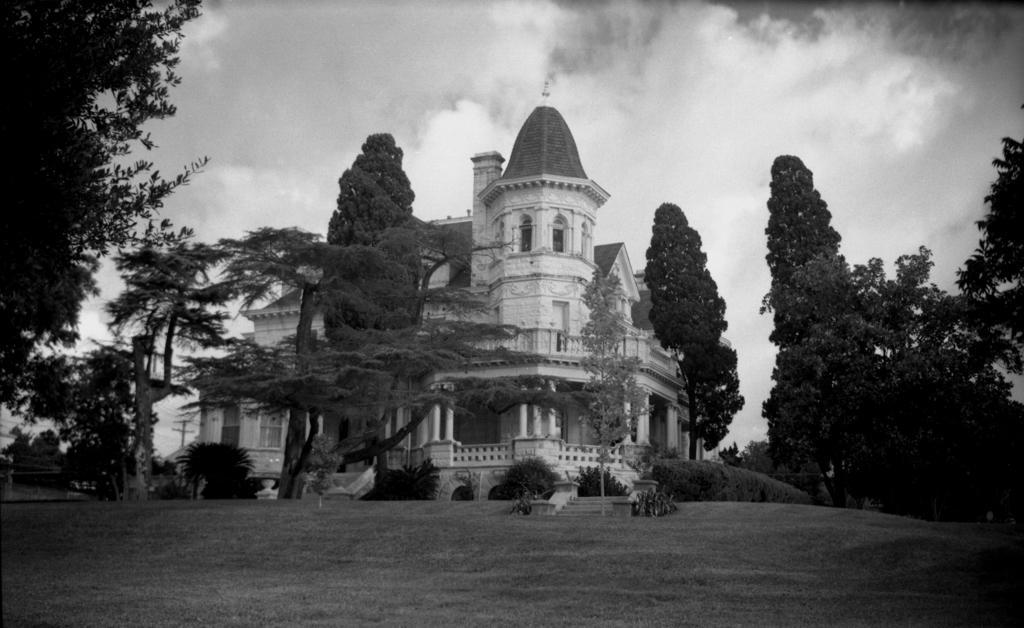How would you summarize this image in a sentence or two? In the center of the image there is a building and trees. On the right side and left side we can see trees. At the bottom there is a grass. In the background we can see sky and clouds. 